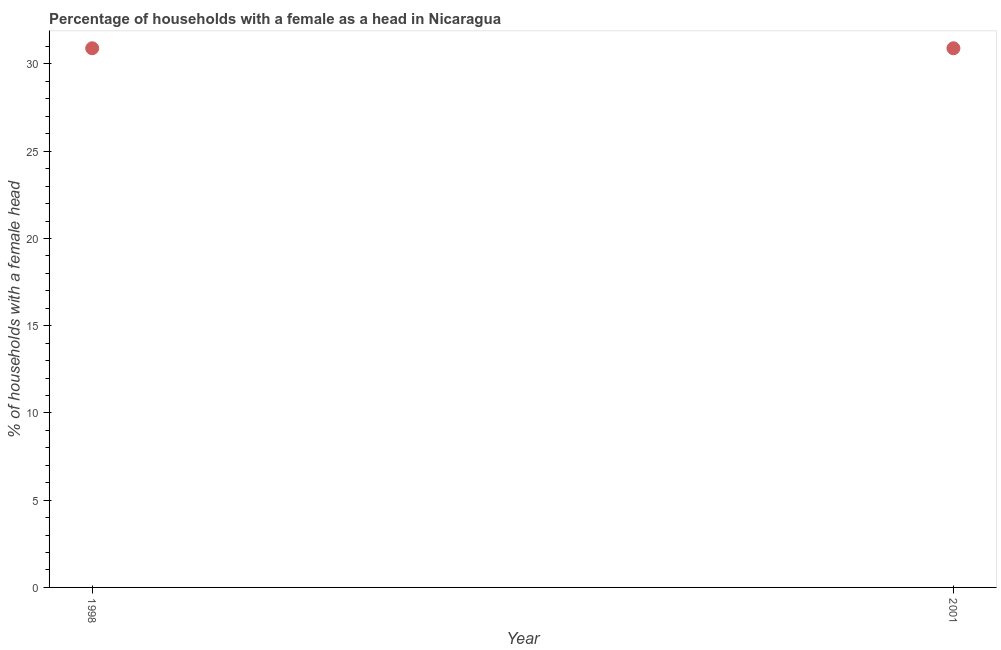What is the number of female supervised households in 1998?
Your answer should be very brief. 30.9. Across all years, what is the maximum number of female supervised households?
Offer a very short reply. 30.9. Across all years, what is the minimum number of female supervised households?
Make the answer very short. 30.9. In which year was the number of female supervised households minimum?
Offer a very short reply. 1998. What is the sum of the number of female supervised households?
Keep it short and to the point. 61.8. What is the average number of female supervised households per year?
Ensure brevity in your answer.  30.9. What is the median number of female supervised households?
Provide a succinct answer. 30.9. What is the ratio of the number of female supervised households in 1998 to that in 2001?
Your answer should be compact. 1. In how many years, is the number of female supervised households greater than the average number of female supervised households taken over all years?
Provide a short and direct response. 0. Does the number of female supervised households monotonically increase over the years?
Give a very brief answer. No. How many dotlines are there?
Give a very brief answer. 1. Are the values on the major ticks of Y-axis written in scientific E-notation?
Make the answer very short. No. What is the title of the graph?
Your answer should be very brief. Percentage of households with a female as a head in Nicaragua. What is the label or title of the X-axis?
Keep it short and to the point. Year. What is the label or title of the Y-axis?
Provide a succinct answer. % of households with a female head. What is the % of households with a female head in 1998?
Your answer should be compact. 30.9. What is the % of households with a female head in 2001?
Provide a short and direct response. 30.9. 